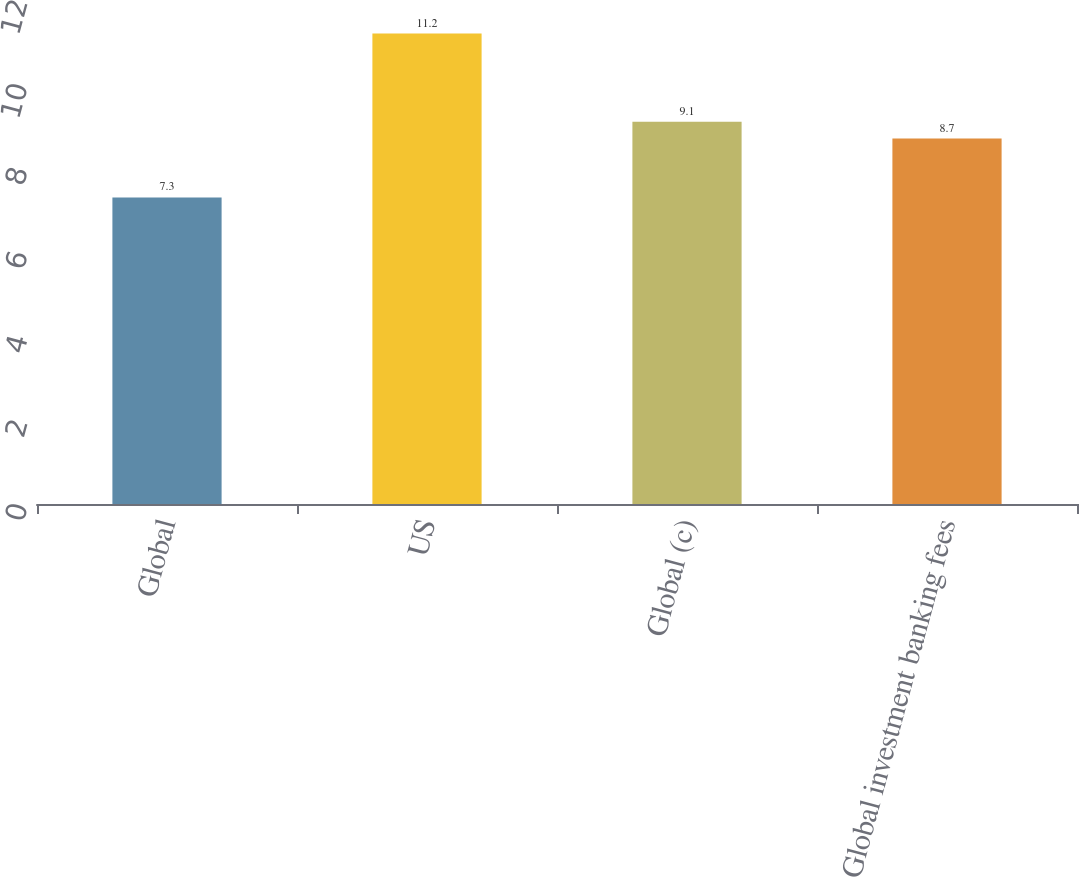Convert chart to OTSL. <chart><loc_0><loc_0><loc_500><loc_500><bar_chart><fcel>Global<fcel>US<fcel>Global (c)<fcel>Global investment banking fees<nl><fcel>7.3<fcel>11.2<fcel>9.1<fcel>8.7<nl></chart> 